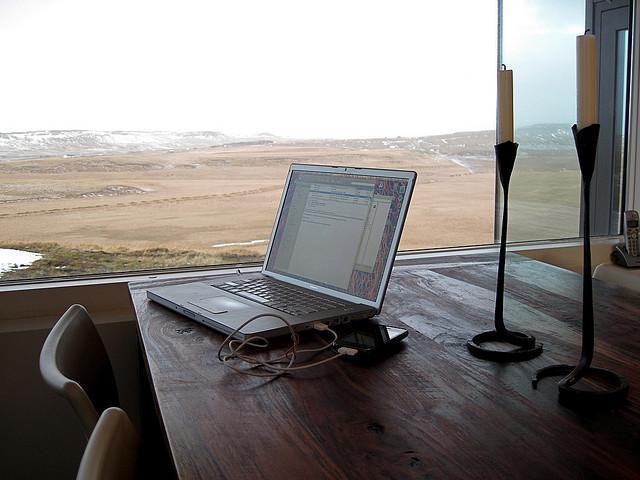How many chairs are there?
Give a very brief answer. 2. How many laptops are there?
Give a very brief answer. 1. 